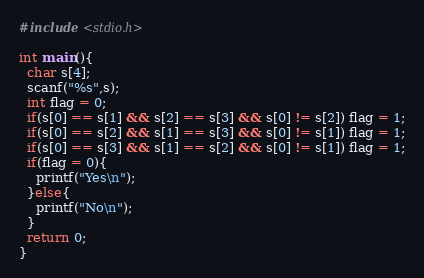<code> <loc_0><loc_0><loc_500><loc_500><_C_>#include <stdio.h>

int main(){
  char s[4];
  scanf("%s",s);
  int flag = 0;
  if(s[0] == s[1] && s[2] == s[3] && s[0] != s[2]) flag = 1;
  if(s[0] == s[2] && s[1] == s[3] && s[0] != s[1]) flag = 1;
  if(s[0] == s[3] && s[1] == s[2] && s[0] != s[1]) flag = 1;
  if(flag = 0){
    printf("Yes\n");
  }else{
    printf("No\n");
  }
  return 0;
}</code> 